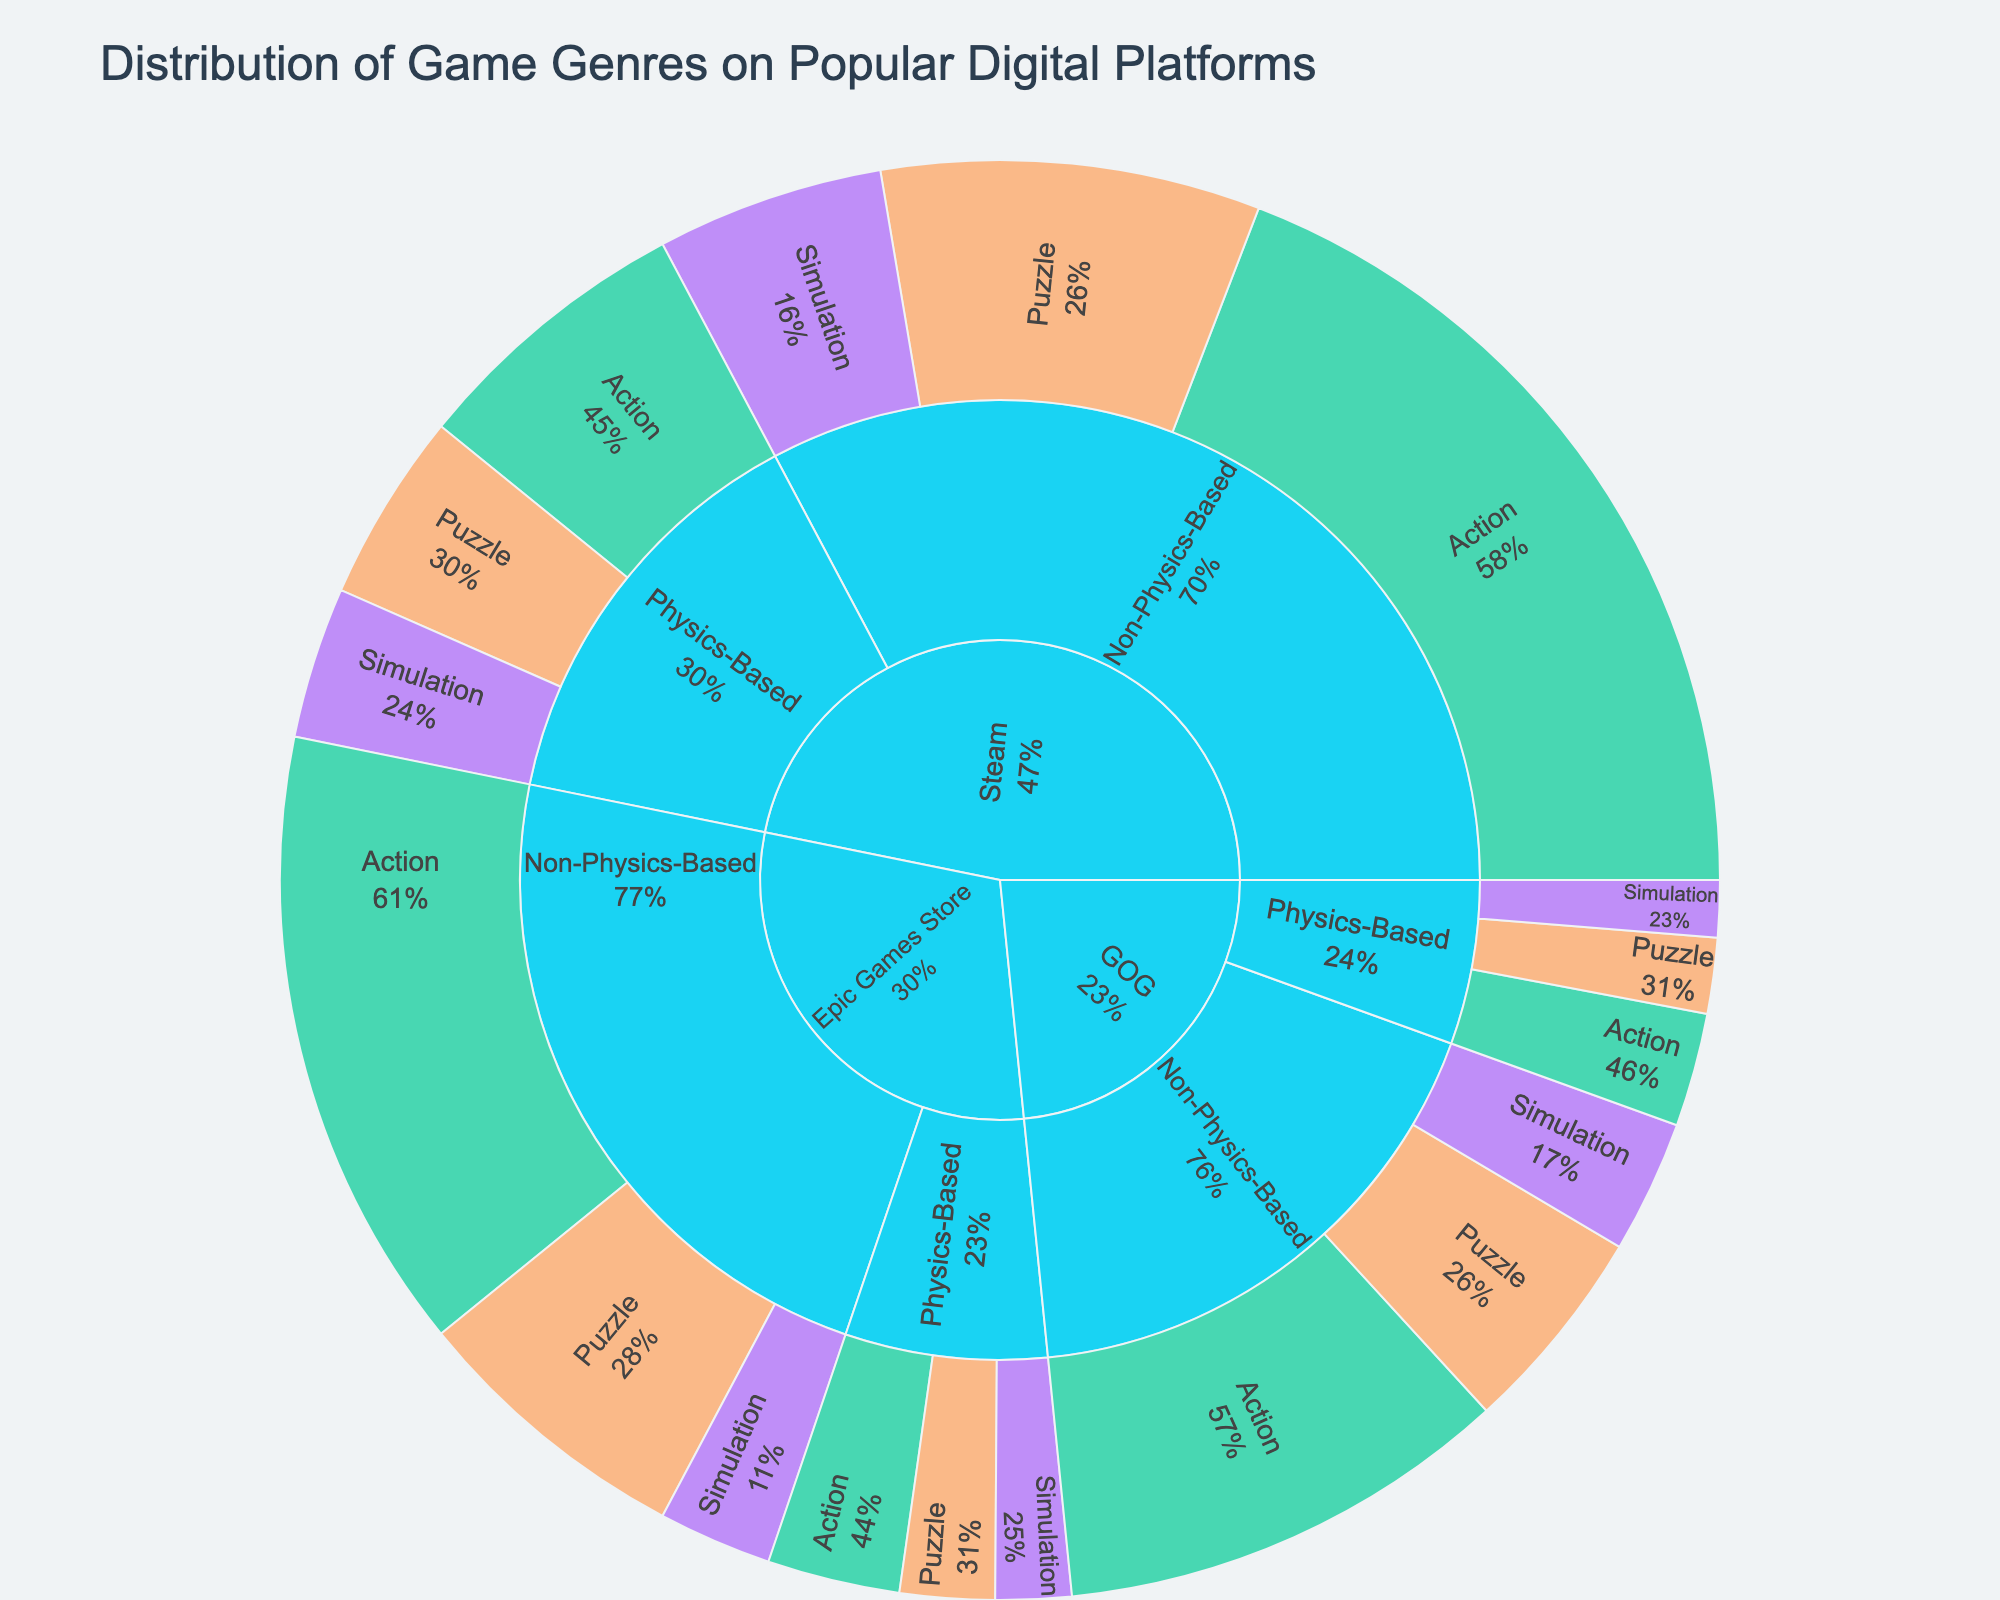What is the total number of Action games listed for Steam? We look at all "Action" games under the "Steam" category. Physics-Based and Non-Physics-Based Action games have values of 15 and 45, respectively. Adding these two gives us 15 + 45 = 60.
Answer: 60 Which game genre has the highest number of Physics-Based games on Steam? To find this, we look at all Physics-Based games under the "Steam" category. The genres and values are Action (15), Puzzle (10), and Simulation (8). Clearly, Action has the highest value among these.
Answer: Action How many more Non-Physics-Based games are there than Physics-Based games on the Epic Games Store? Under "Epic Games Store," we sum all the values for Physics-Based (7 + 5 + 4 = 16) and Non-Physics-Based games (33 + 15 + 6 = 54) and find the difference, which is 54 - 16 = 38.
Answer: 38 Which platform has the least number of Simulation games? We sum the values for Simulation games across all categories: Steam (8 + 12 = 20), Epic Games Store (4 + 6 = 10), and GOG (3 + 7 = 10). Both Epic Games Store and GOG have 10 Simulation games, which is the minimum.
Answer: Epic Games Store and GOG What proportion of all Puzzle games on GOG are Physics-Based? The total number of Puzzle games on GOG is 4 (Physics-Based) + 11 (Non-Physics-Based) = 15. The proportion of Physics-Based Puzzle games is 4/15.
Answer: 4/15 Which genre has a higher proportion of Physics-Based games on Steam compared to Epic Games Store? On Steam, the proportions for Physics-Based games are Action: 15/(15+45)=15/60=1/4, Puzzle: 10/(10+20)=1/3, Simulation: 8/(8+12)=2/5. On Epic Games Store, the proportions are Action: 7/(7+33)=7/40, Puzzle: 5/(5+15)=1/4, Simulation: 4/(4+6)=2/5. Comparing proportions, for Action and Puzzle, Steam has higher proportions (1/4 vs 7/40 and 1/3 vs 1/4).
Answer: Action and Puzzle How many Physics-Based games are listed on GOG? We add the values of all Physics-Based games under the GOG category: Action (6), Puzzle (4), and Simulation (3). So, 6 + 4 + 3 = 13.
Answer: 13 What percentage of all Action games on Epic Games Store are Non-Physics-Based? The total number of Action games on Epic Games Store is 7 (Physics-Based) + 33 (Non-Physics-Based) = 40. The percentage of Non-Physics-Based Action games is (33/40) * 100%.
Answer: 82.5% 